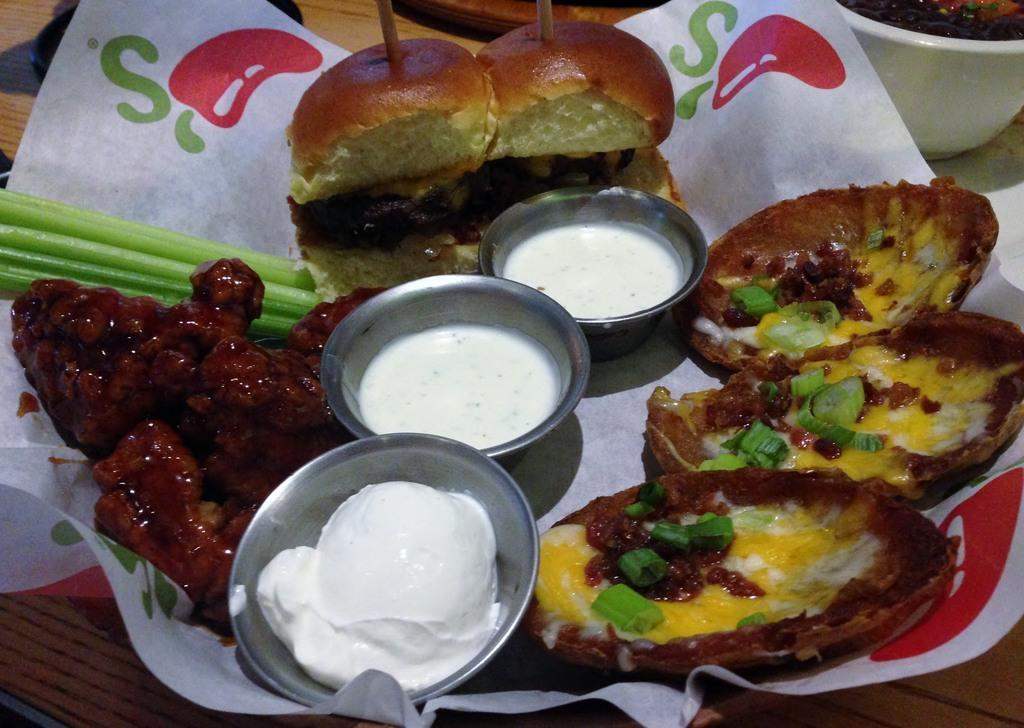Describe this image in one or two sentences. In this image there is one basket, and in the basket there are some burgers food items and bowls. In the bowls there is ice cream and curd and in the background there is another bowl, in the bowl there is some food and also there are some objects. At the bottom it looks like a table. 